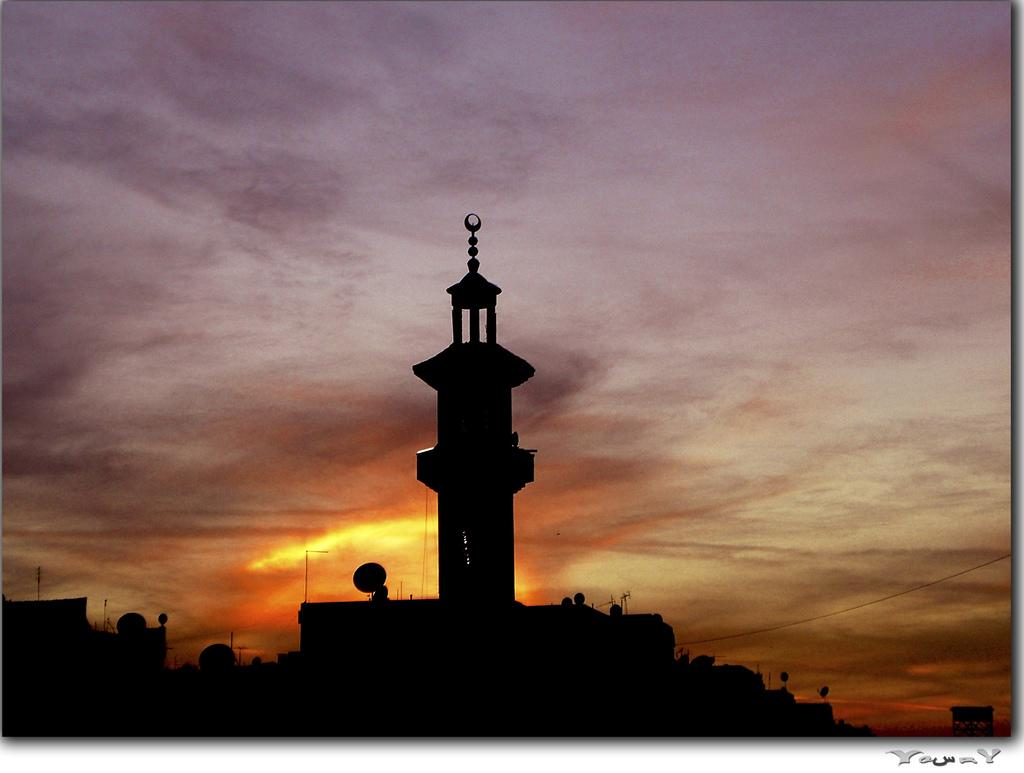What type of image is being described? The image is a photo. What can be seen in the photo? There are buildings visible in the image. What is visible in the background of the photo? The sky is visible in the background of the image. What is the condition of the sky in the photo? Sunlight is present in the sky. Is there any text in the photo? Yes, there is some text in the bottom right corner of the image. How many sheep are visible in the photo? There are no sheep present in the photo. What type of tax is being discussed in the text in the bottom right corner of the photo? There is no text discussing any tax in the bottom right corner of the photo. 